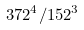<formula> <loc_0><loc_0><loc_500><loc_500>3 7 2 ^ { 4 } / 1 5 2 ^ { 3 }</formula> 